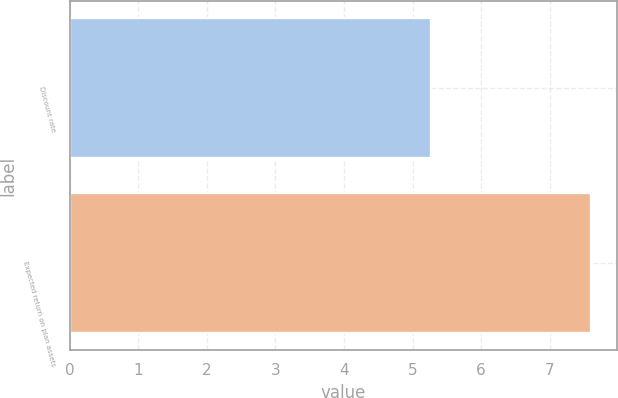Convert chart to OTSL. <chart><loc_0><loc_0><loc_500><loc_500><bar_chart><fcel>Discount rate<fcel>Expected return on plan assets<nl><fcel>5.27<fcel>7.6<nl></chart> 